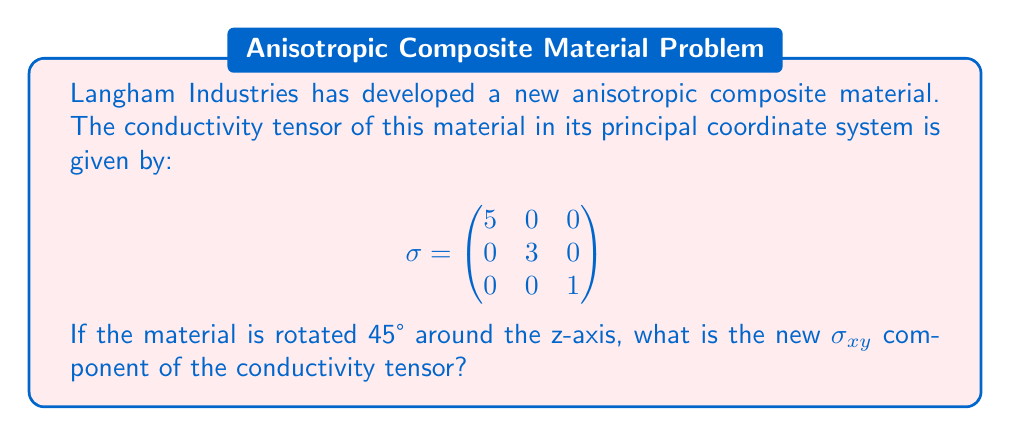What is the answer to this math problem? To solve this problem, we need to follow these steps:

1) First, recall the rotation matrix for a 45° rotation around the z-axis:

   $$R = \begin{pmatrix}
   \cos 45° & -\sin 45° & 0 \\
   \sin 45° & \cos 45° & 0 \\
   0 & 0 & 1
   \end{pmatrix} = \begin{pmatrix}
   \frac{1}{\sqrt{2}} & -\frac{1}{\sqrt{2}} & 0 \\
   \frac{1}{\sqrt{2}} & \frac{1}{\sqrt{2}} & 0 \\
   0 & 0 & 1
   \end{pmatrix}$$

2) The transformed conductivity tensor $\sigma'$ is given by:

   $$\sigma' = R \sigma R^T$$

3) Let's perform this multiplication step by step:

   First, $\sigma R^T$:
   $$\begin{pmatrix}
   5 & 0 & 0 \\
   0 & 3 & 0 \\
   0 & 0 & 1
   \end{pmatrix} \begin{pmatrix}
   \frac{1}{\sqrt{2}} & \frac{1}{\sqrt{2}} & 0 \\
   -\frac{1}{\sqrt{2}} & \frac{1}{\sqrt{2}} & 0 \\
   0 & 0 & 1
   \end{pmatrix} = \begin{pmatrix}
   \frac{5}{\sqrt{2}} & \frac{5}{\sqrt{2}} & 0 \\
   -\frac{3}{\sqrt{2}} & \frac{3}{\sqrt{2}} & 0 \\
   0 & 0 & 1
   \end{pmatrix}$$

   Now, $R(\sigma R^T)$:
   $$\begin{pmatrix}
   \frac{1}{\sqrt{2}} & -\frac{1}{\sqrt{2}} & 0 \\
   \frac{1}{\sqrt{2}} & \frac{1}{\sqrt{2}} & 0 \\
   0 & 0 & 1
   \end{pmatrix} \begin{pmatrix}
   \frac{5}{\sqrt{2}} & \frac{5}{\sqrt{2}} & 0 \\
   -\frac{3}{\sqrt{2}} & \frac{3}{\sqrt{2}} & 0 \\
   0 & 0 & 1
   \end{pmatrix}$$

4) The $\sigma_{xy}$ component is the element in the first row, second column of this resulting matrix. We only need to calculate this element:

   $$\sigma_{xy} = \frac{1}{\sqrt{2}} \cdot \frac{5}{\sqrt{2}} + (-\frac{1}{\sqrt{2}}) \cdot \frac{3}{\sqrt{2}} = \frac{5-3}{2} = 1$$

Thus, the new $\sigma_{xy}$ component after rotation is 1.
Answer: 1 